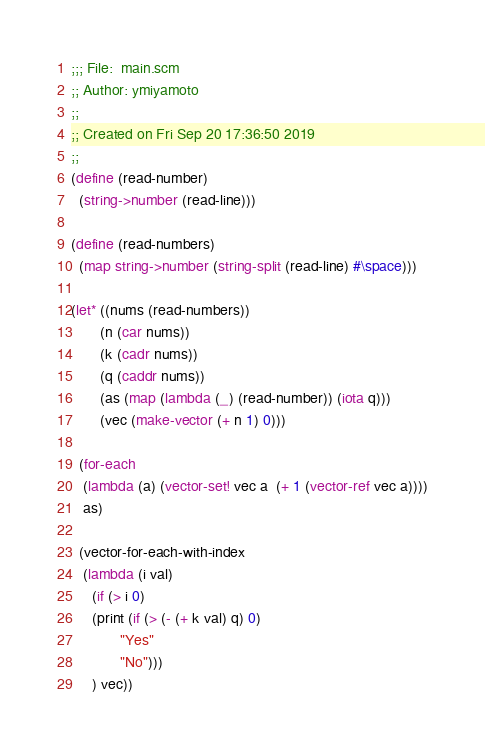Convert code to text. <code><loc_0><loc_0><loc_500><loc_500><_Scheme_>;;; File:  main.scm
;; Author: ymiyamoto
;;
;; Created on Fri Sep 20 17:36:50 2019
;;
(define (read-number)
  (string->number (read-line)))

(define (read-numbers)
  (map string->number (string-split (read-line) #\space)))

(let* ((nums (read-numbers))
       (n (car nums))
       (k (cadr nums))
       (q (caddr nums))
       (as (map (lambda (_) (read-number)) (iota q)))
       (vec (make-vector (+ n 1) 0)))

  (for-each
   (lambda (a) (vector-set! vec a  (+ 1 (vector-ref vec a))))
   as)

  (vector-for-each-with-index
   (lambda (i val)
     (if (> i 0)
	 (print (if (> (- (+ k val) q) 0)
		    "Yes"
		    "No")))
     ) vec))
</code> 